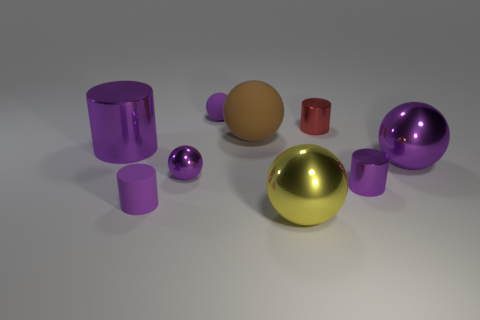How does the color distribution of the objects contribute to the overall composition of the image? The image displays a harmonious color distribution with objects exhibiting vibrant purple, muted gold, and deep red hues. These colors add a dynamic but balanced visual interest, creating a pleasing aesthetic that guides the eye through the composition. 